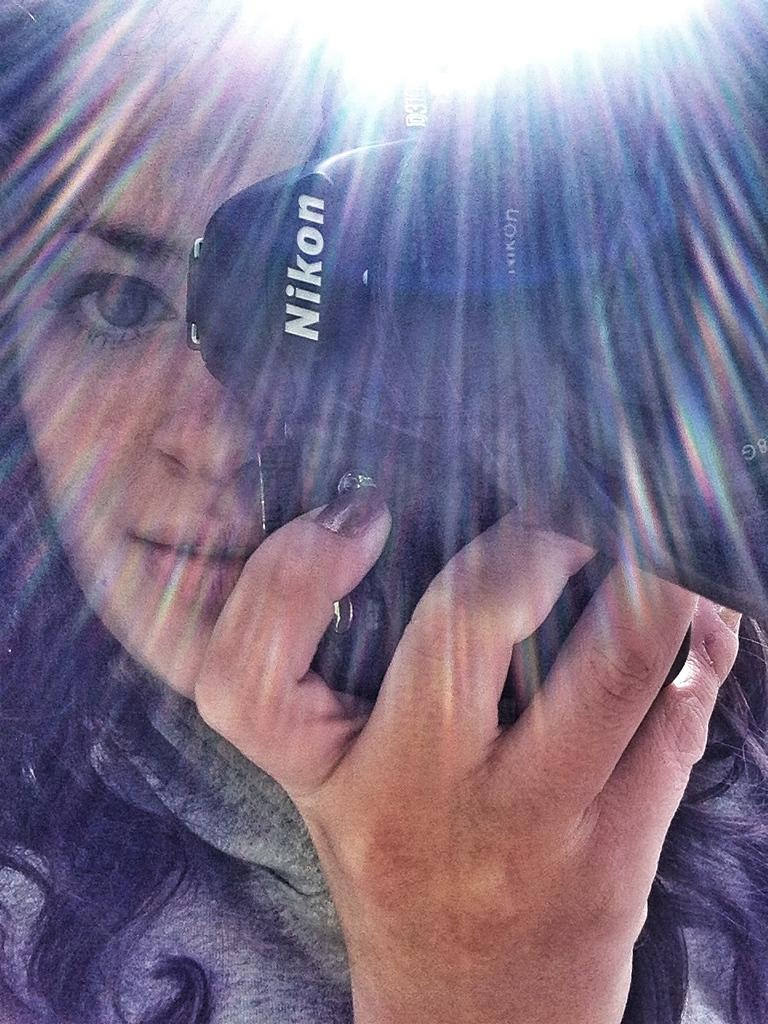<image>
Share a concise interpretation of the image provided. A girl holds up a Nikon camera to take a picture 